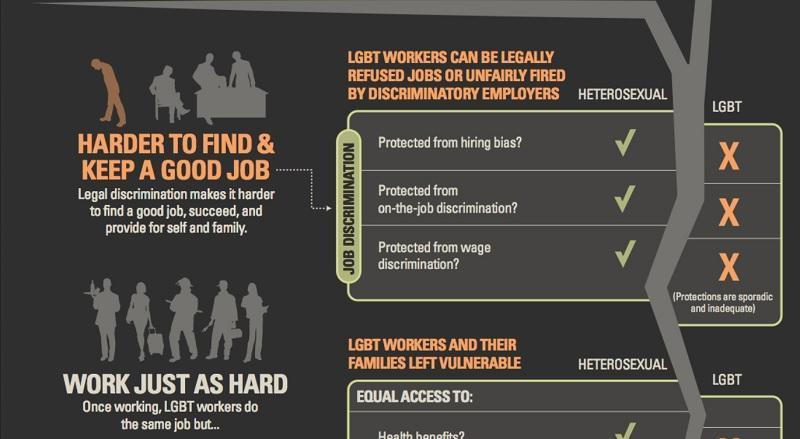how many areas do LGBT face job discrimination
Answer the question with a short phrase. 3 what are the 2 types of genders being considered in job discrimination heterosexual, lgbt 